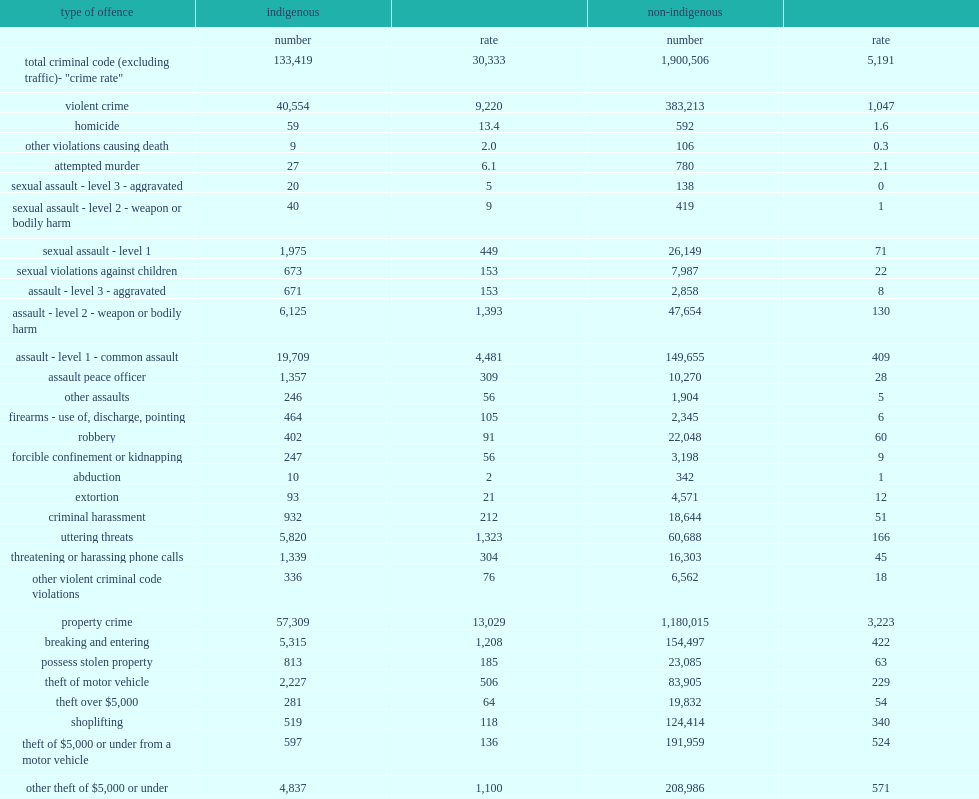How many times was the rate of mischief in indigenous communities higher than in non-indigenous communities in 2018? 15.465662. What is the percentage did police reported crimes in indigenous communities was mischief? 0.304379. What is the percentage did police reported crimes in non-indigenous communities was mischief? 0.115007. What percentage did violent offences account for which was reported by police serving majority indigenous populations? 0.30396. What percentage did violent offences account for which was reported by police serving majority non-indigenous populations? 0.201637. What is the number of incidents of violent crime per 100,000 population did police serving primarily indigenous communities report in 2018? 9220.0. How many times were the number of incidents of violent crime per 100,000 population reported by police serving primarily indigenous communities in 2018 higher than those primarily serving non-indigenous communities? 8.806113. How many times have the rate of common assault reported by police serving majority indigenous populations been higher in indigenous communities than in non-indigenous communities? 10.95599. What percentage of violent crime did the rate of common assault reported by police serving majority non-indigenous populations represent? 0.39064. What percentage of violent crime did the rate of common assault reported by police serving majority indigenous populations represent? 0.485994. Would you be able to parse every entry in this table? {'header': ['type of offence', 'indigenous', '', 'non-indigenous', ''], 'rows': [['', 'number', 'rate', 'number', 'rate'], ['total criminal code (excluding traffic)- "crime rate"', '133,419', '30,333', '1,900,506', '5,191'], ['violent crime', '40,554', '9,220', '383,213', '1,047'], ['homicide', '59', '13.4', '592', '1.6'], ['other violations causing death', '9', '2.0', '106', '0.3'], ['attempted murder', '27', '6.1', '780', '2.1'], ['sexual assault - level 3 - aggravated', '20', '5', '138', '0'], ['sexual assault - level 2 - weapon or bodily harm', '40', '9', '419', '1'], ['sexual assault - level 1', '1,975', '449', '26,149', '71'], ['sexual violations against children', '673', '153', '7,987', '22'], ['assault - level 3 - aggravated', '671', '153', '2,858', '8'], ['assault - level 2 - weapon or bodily harm', '6,125', '1,393', '47,654', '130'], ['assault - level 1 - common assault', '19,709', '4,481', '149,655', '409'], ['assault peace officer', '1,357', '309', '10,270', '28'], ['other assaults', '246', '56', '1,904', '5'], ['firearms - use of, discharge, pointing', '464', '105', '2,345', '6'], ['robbery', '402', '91', '22,048', '60'], ['forcible confinement or kidnapping', '247', '56', '3,198', '9'], ['abduction', '10', '2', '342', '1'], ['extortion', '93', '21', '4,571', '12'], ['criminal harassment', '932', '212', '18,644', '51'], ['uttering threats', '5,820', '1,323', '60,688', '166'], ['threatening or harassing phone calls', '1,339', '304', '16,303', '45'], ['other violent criminal code violations', '336', '76', '6,562', '18'], ['property crime', '57,309', '13,029', '1,180,015', '3,223'], ['breaking and entering', '5,315', '1,208', '154,497', '422'], ['possess stolen property', '813', '185', '23,085', '63'], ['theft of motor vehicle', '2,227', '506', '83,905', '229'], ['theft over $5,000', '281', '64', '19,832', '54'], ['shoplifting', '519', '118', '124,414', '340'], ['theft of $5,000 or under from a motor vehicle', '597', '136', '191,959', '524'], ['other theft of $5,000 or under', '4,837', '1,100', '208,986', '571'], ['fraud', '1,162', '264', '128,247', '350'], ['identity fraud', '175', '40', '19,409', '53'], ['mischief', '40,610', '9,233', '218,454', '597'], ['arson', '773', '176', '7,227', '20'], ['other criminal code offences', '35,556', '8,084', '337,278', '921'], ['weapons violations', '1,066', '242', '15,544', '42'], ['disturbing the peace', '16,510', '3,754', '77,868', '213'], ['administration of justice violations', '15,607', '3,548', '211,257', '577'], ['other violations', '2,373', '540', '32,609', '89'], ['criminal code traffic violations', '8,773', '1,995', '116,771', '319'], ['impaired driving', '7,226', '1,643', '63,367', '173'], ['other criminal code traffic violations', '1,547', '352', '53,404', '146'], ['drug offences', '3,231', '735', '80,252', '219'], ['cannabis related', '1,216', '276', '34,679', '95'], ['cocaine related', '901', '205', '13,424', '37'], ['other drugs', '1,114', '253', '32,149', '88'], ['other federal statute violations', '1,685', '383', '24,399', '67'], ['youth criminal justice act', '360', '82', '4,463', '12'], ['other federal statutes', '1,325', '301', '19,936', '54'], ['total - all violations', '147,108', '33,446', '2,121,928', '5,796']]} 